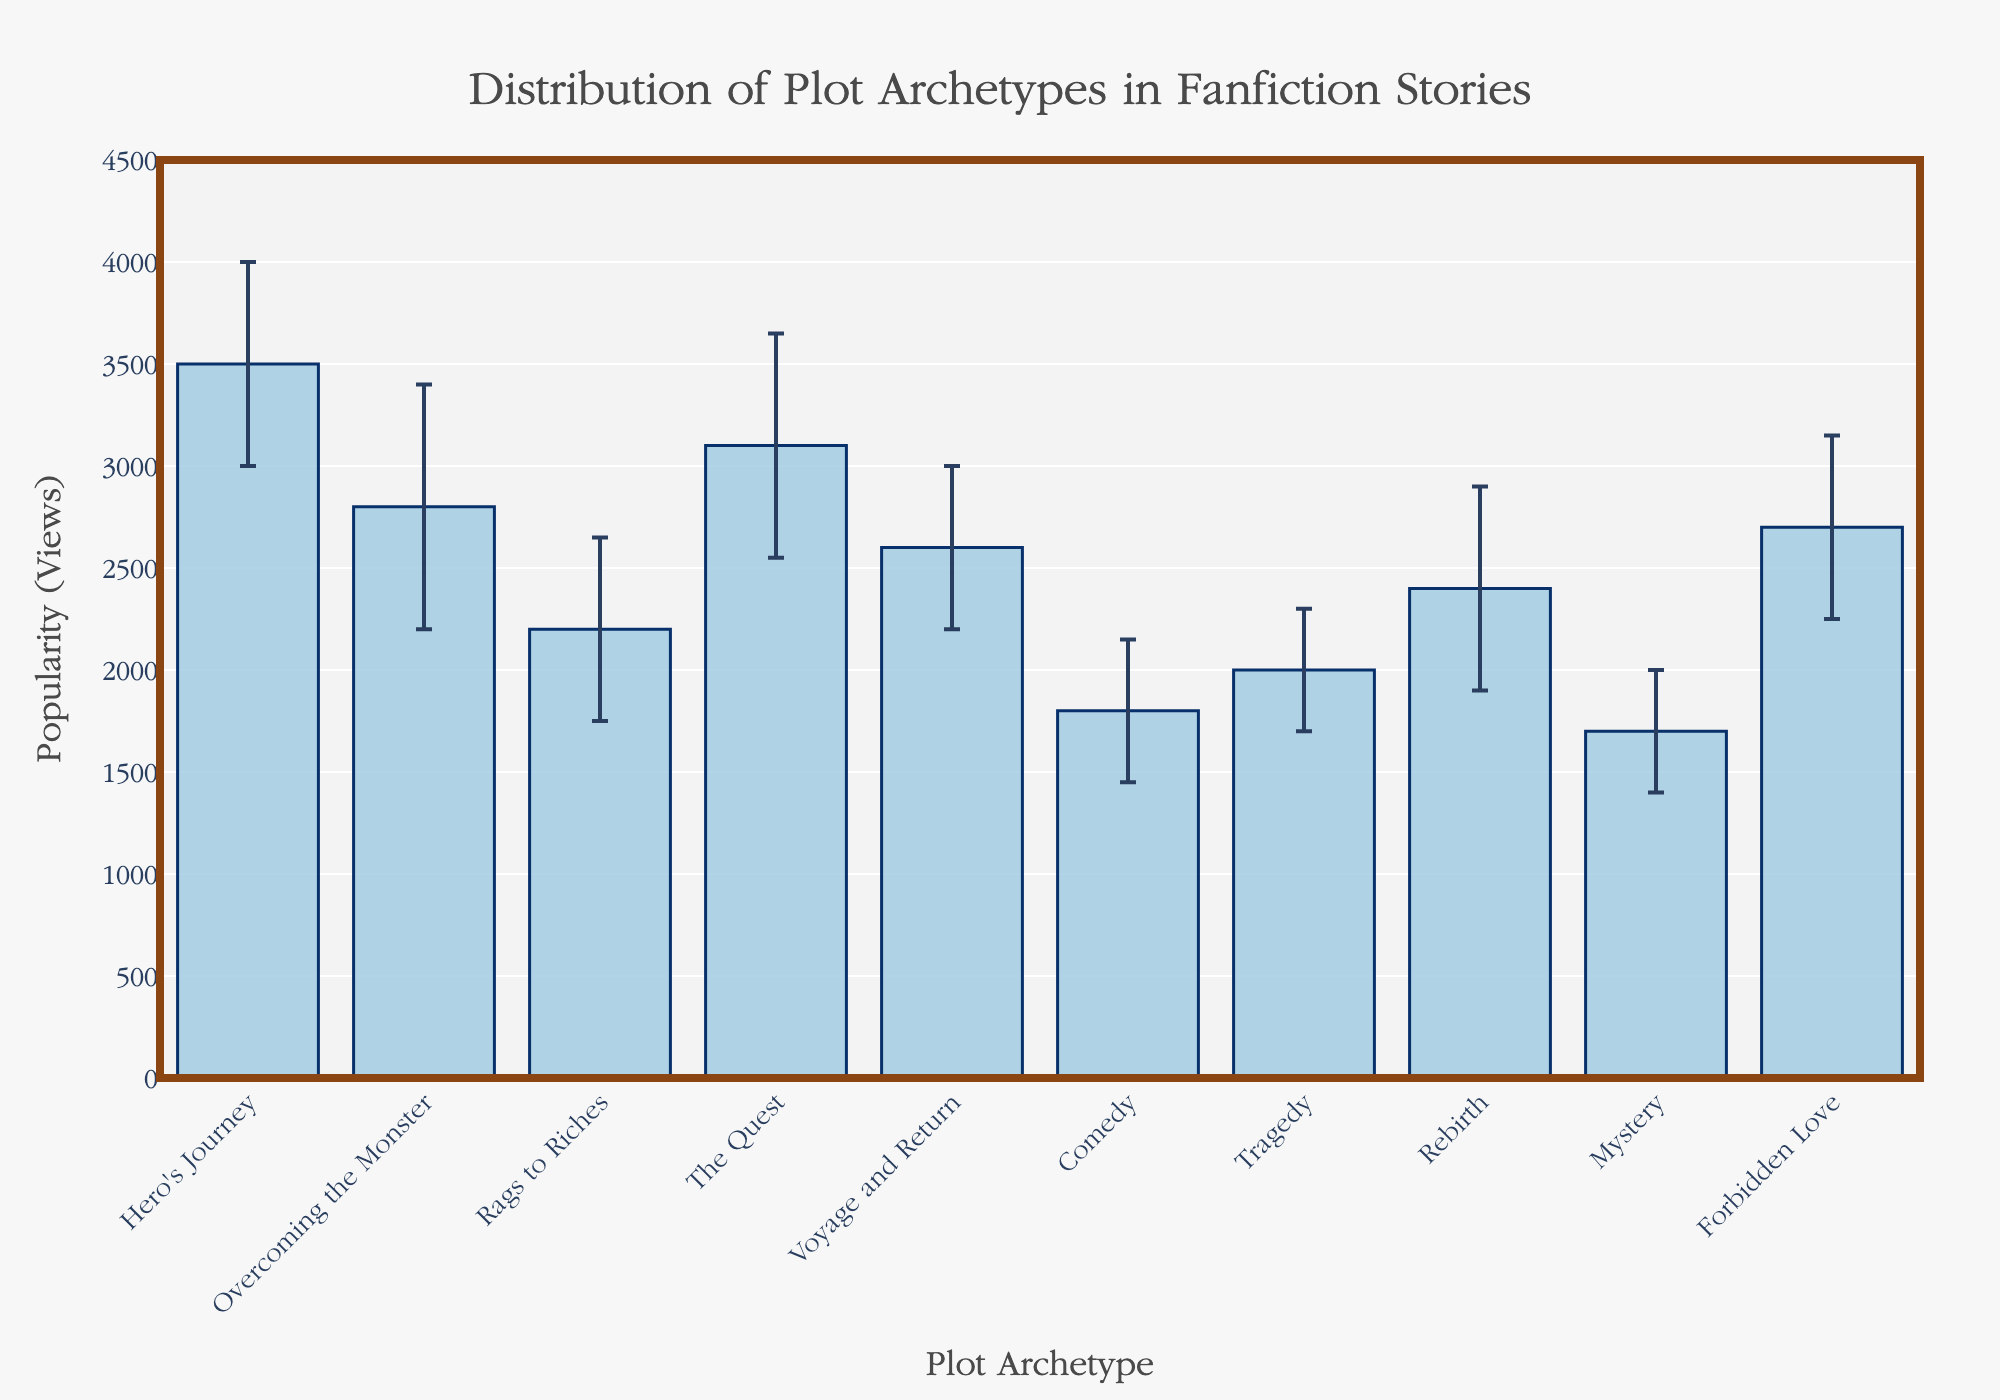What's the most popular plot archetype based on mean views? The highest bar indicates the most popular plot archetype, which corresponds to the 'Hero's Journey' with a mean popularity (views) of 3500.
Answer: Hero's Journey Which plot archetype has the highest standard deviation in views? Look for the plot archetype with the longest error bar. 'Overcoming the Monster' has the highest standard deviation of 600 views.
Answer: Overcoming the Monster What is the combined mean popularity of 'Voyage and Return' and 'Forbidden Love'? Adding the mean popularity (views) of 'Voyage and Return' (2600) and 'Forbidden Love' (2700): 2600 + 2700 = 5300.
Answer: 5300 Which archetype is less popular: 'Tragedy' or 'Rebirth'? Compare the heights of the bars for 'Tragedy' (2000) and 'Rebirth' (2400); 'Tragedy' is less popular.
Answer: Tragedy What is the difference in mean popularity between 'Hero's Journey' and 'Comedy'? Subtract the mean popularity (views) of 'Comedy' (1800) from 'Hero's Journey' (3500): 3500 - 1800 = 1700.
Answer: 1700 How many archetypes have a mean popularity above 2500? Count the bars that surpass the 2500 mark: 'Hero's Journey', 'Overcoming the Monster', 'The Quest', 'Forbidden Love'. There are 4 archetypes.
Answer: 4 What is the average popularity of 'Mystery' and 'Comedy'? Add the mean popularity (views) of 'Mystery' (1700) and 'Comedy' (1800) and divide by 2: (1700 + 1800) / 2 = 1750.
Answer: 1750 Are there more archetypes with mean popularity above or below 2500? Count the number of bars above (Hero's Journey, Overcoming the Monster, The Quest, Forbidden Love - 4) and below (Rags to Riches, Voyage and Return, Comedy, Tragedy, Rebirth, Mystery - 6) 2500. There are more below.
Answer: Below What is the range of the y-axis? The y-axis ranges from 0 to 4500 as indicated by the axis labels.
Answer: 0 to 4500 Which archetype has the least variation in popularity? The shortest error bar indicates the least variation. 'Tragedy' has the smallest standard deviation of 300 views.
Answer: Tragedy 